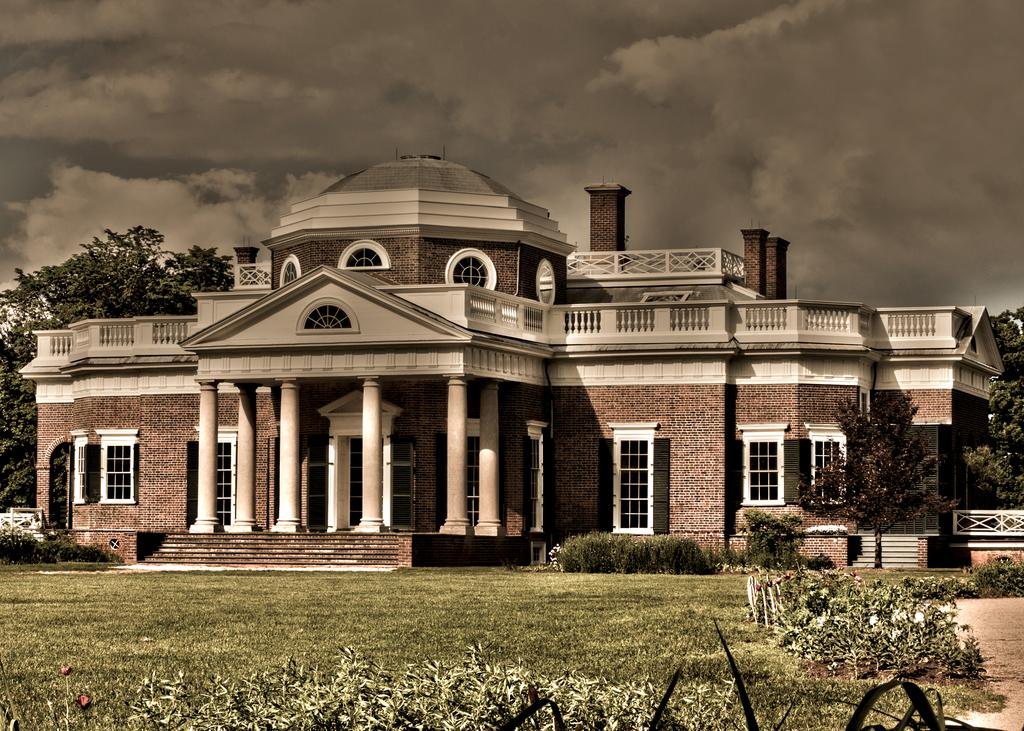What type of vegetation can be seen in the image? There are bushes and grass in the image. What type of structure is present in the image? There is a building with stairs in the image. What is surrounding the building in the image? There are trees around the building in the image. What can be seen in the sky at the top of the image? There are clouds visible in the sky at the top of the image. What type of fiction is being read by the trees in the image? There is no fiction or reading activity present in the image; it features bushes, grass, a building, trees, and clouds. 